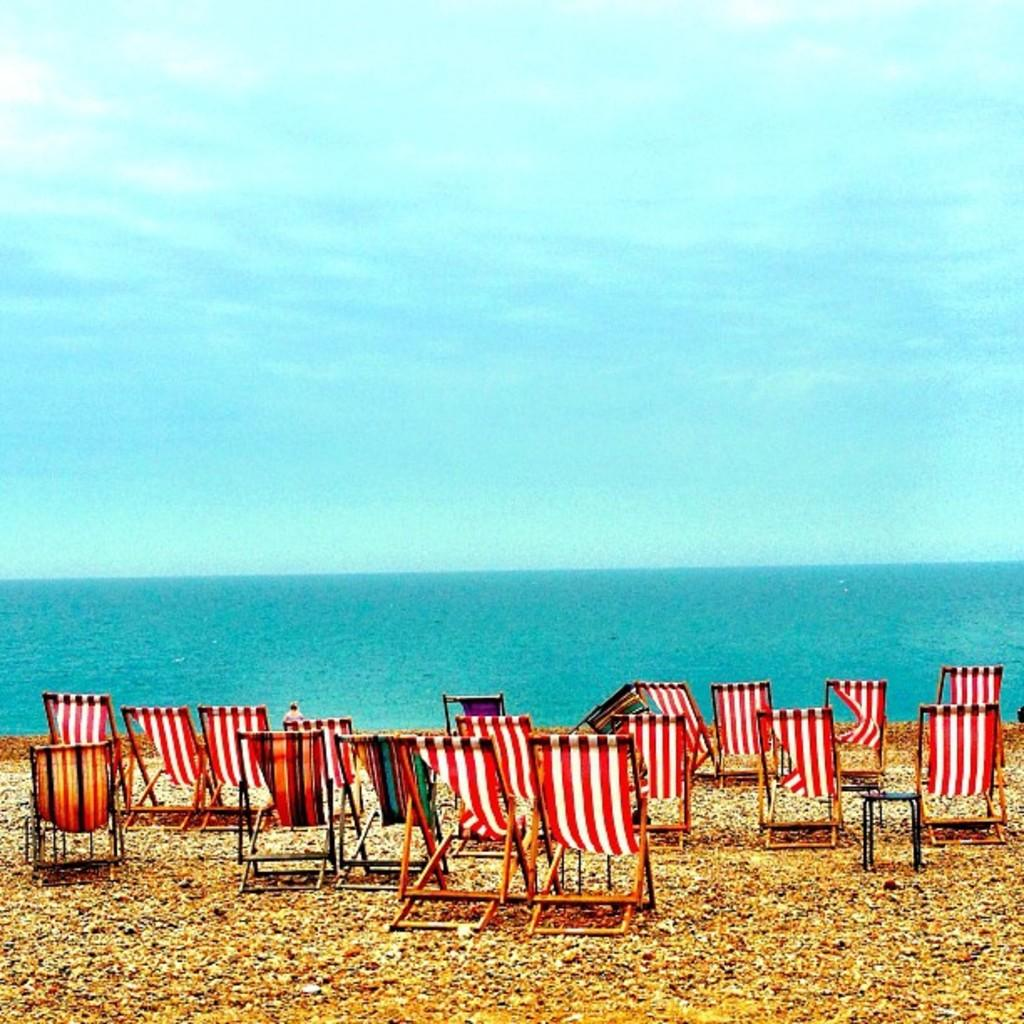What type of furniture is present in the image? There are chairs in the image. Where are the chairs located? The chairs are placed on the land. What can be seen in the background of the image? There is an ocean and the sky visible in the background of the image. What type of soup is being served in the image? There is no soup present in the image; it features chairs placed on the land with an ocean and sky in the background. 